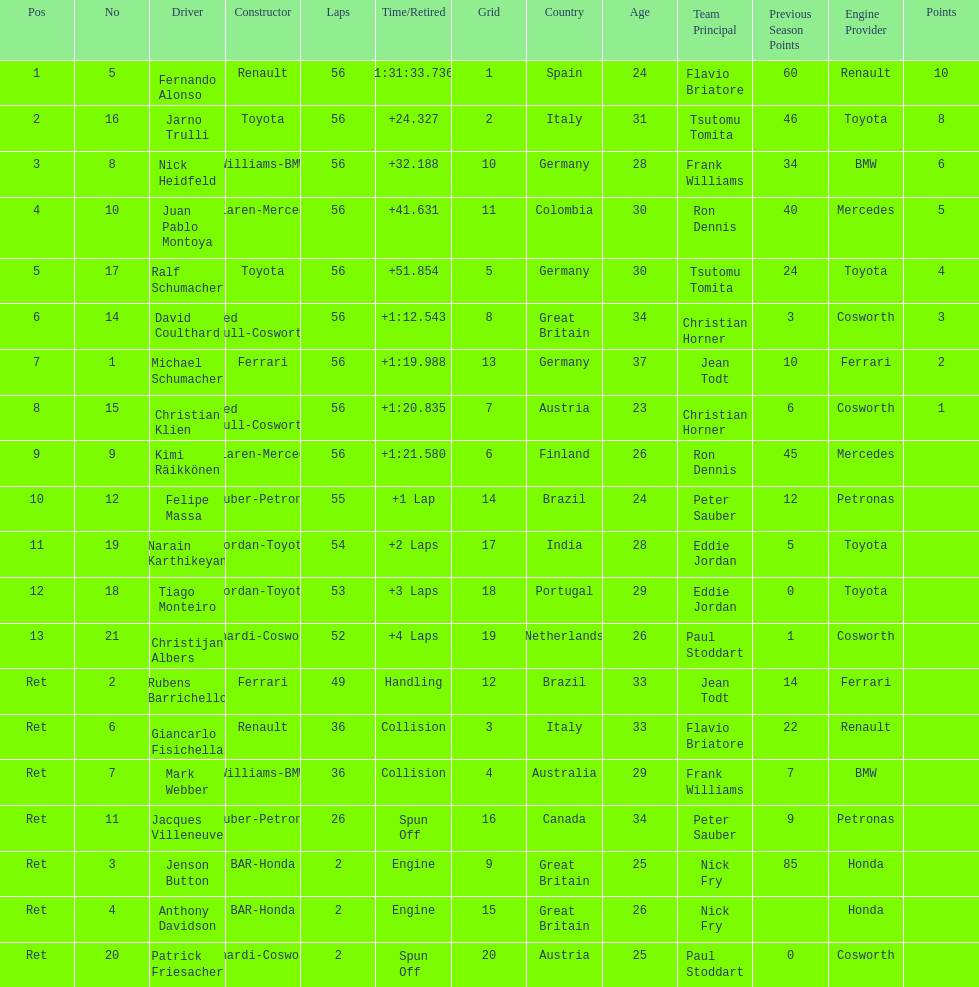How long did it take for heidfeld to finish? 1:31:65.924. 